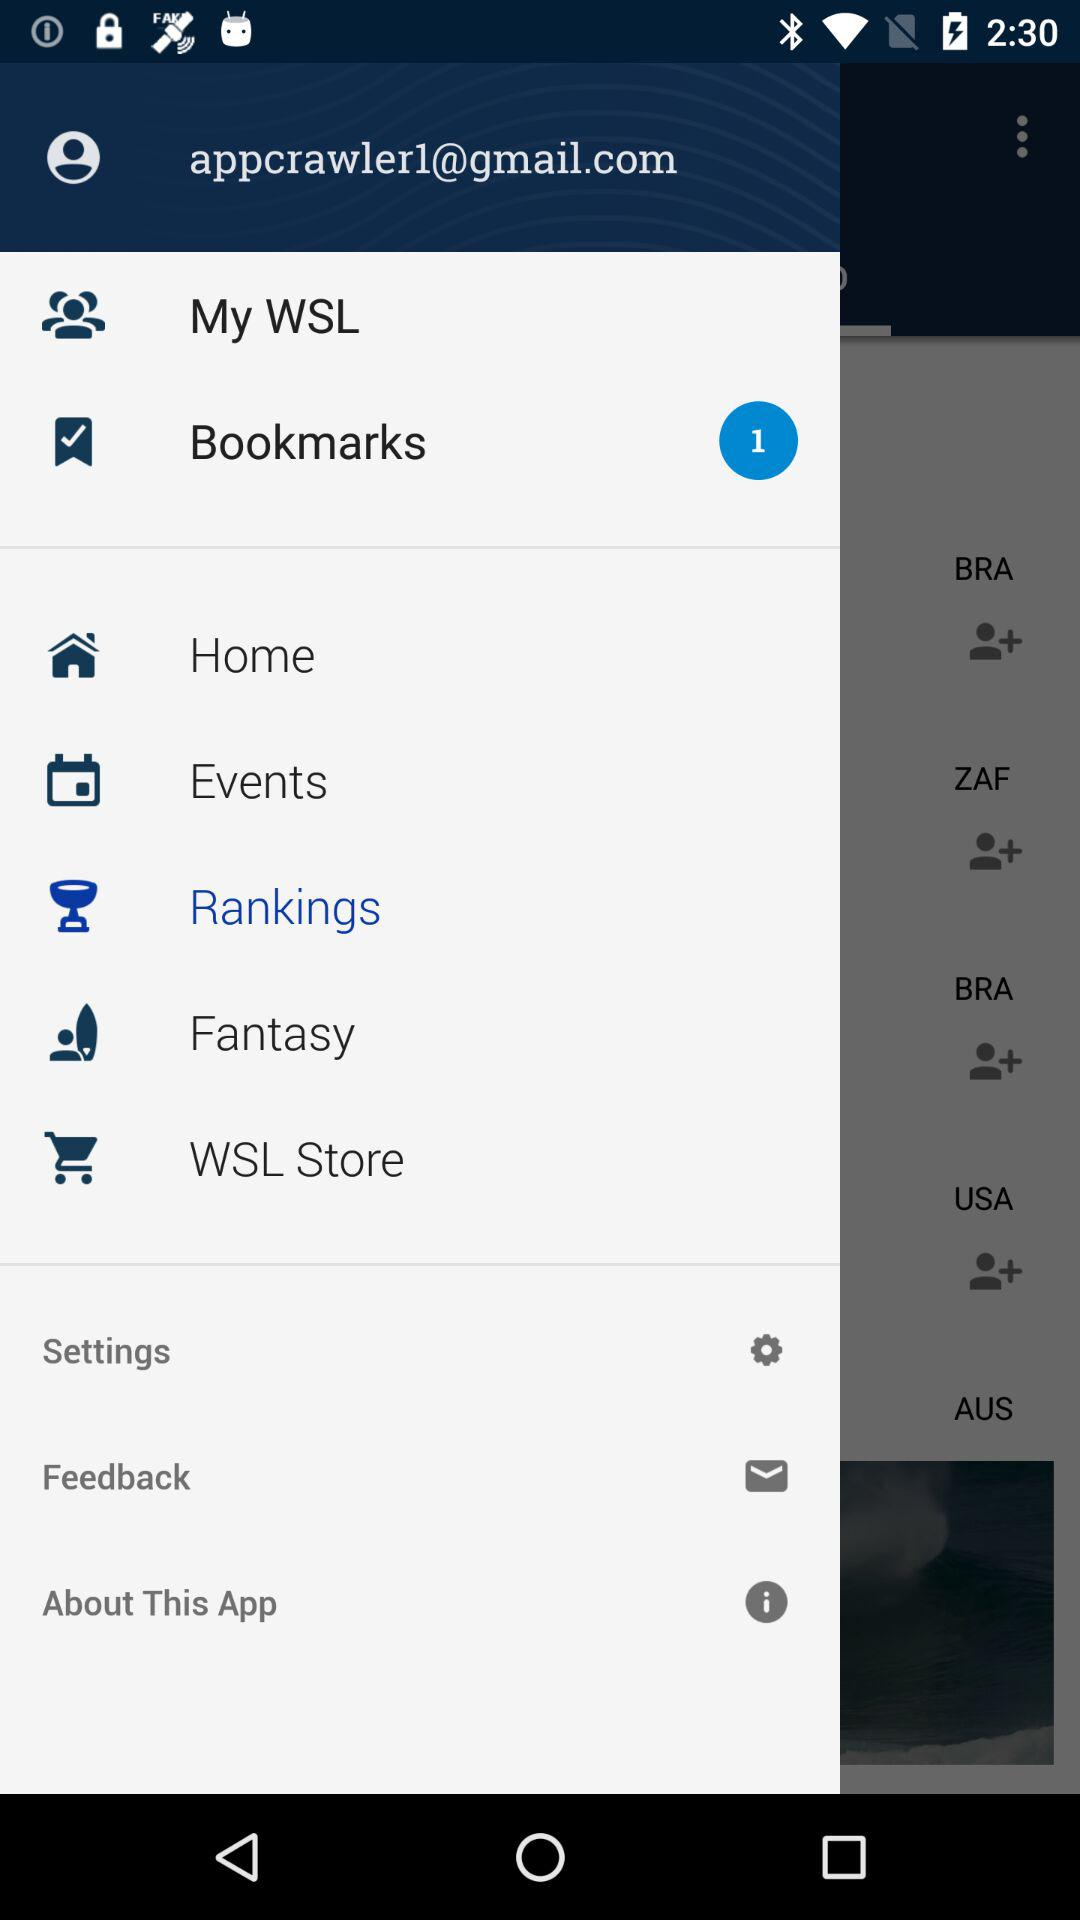What's the count of bookmarks? The count of bookmarks is 1. 